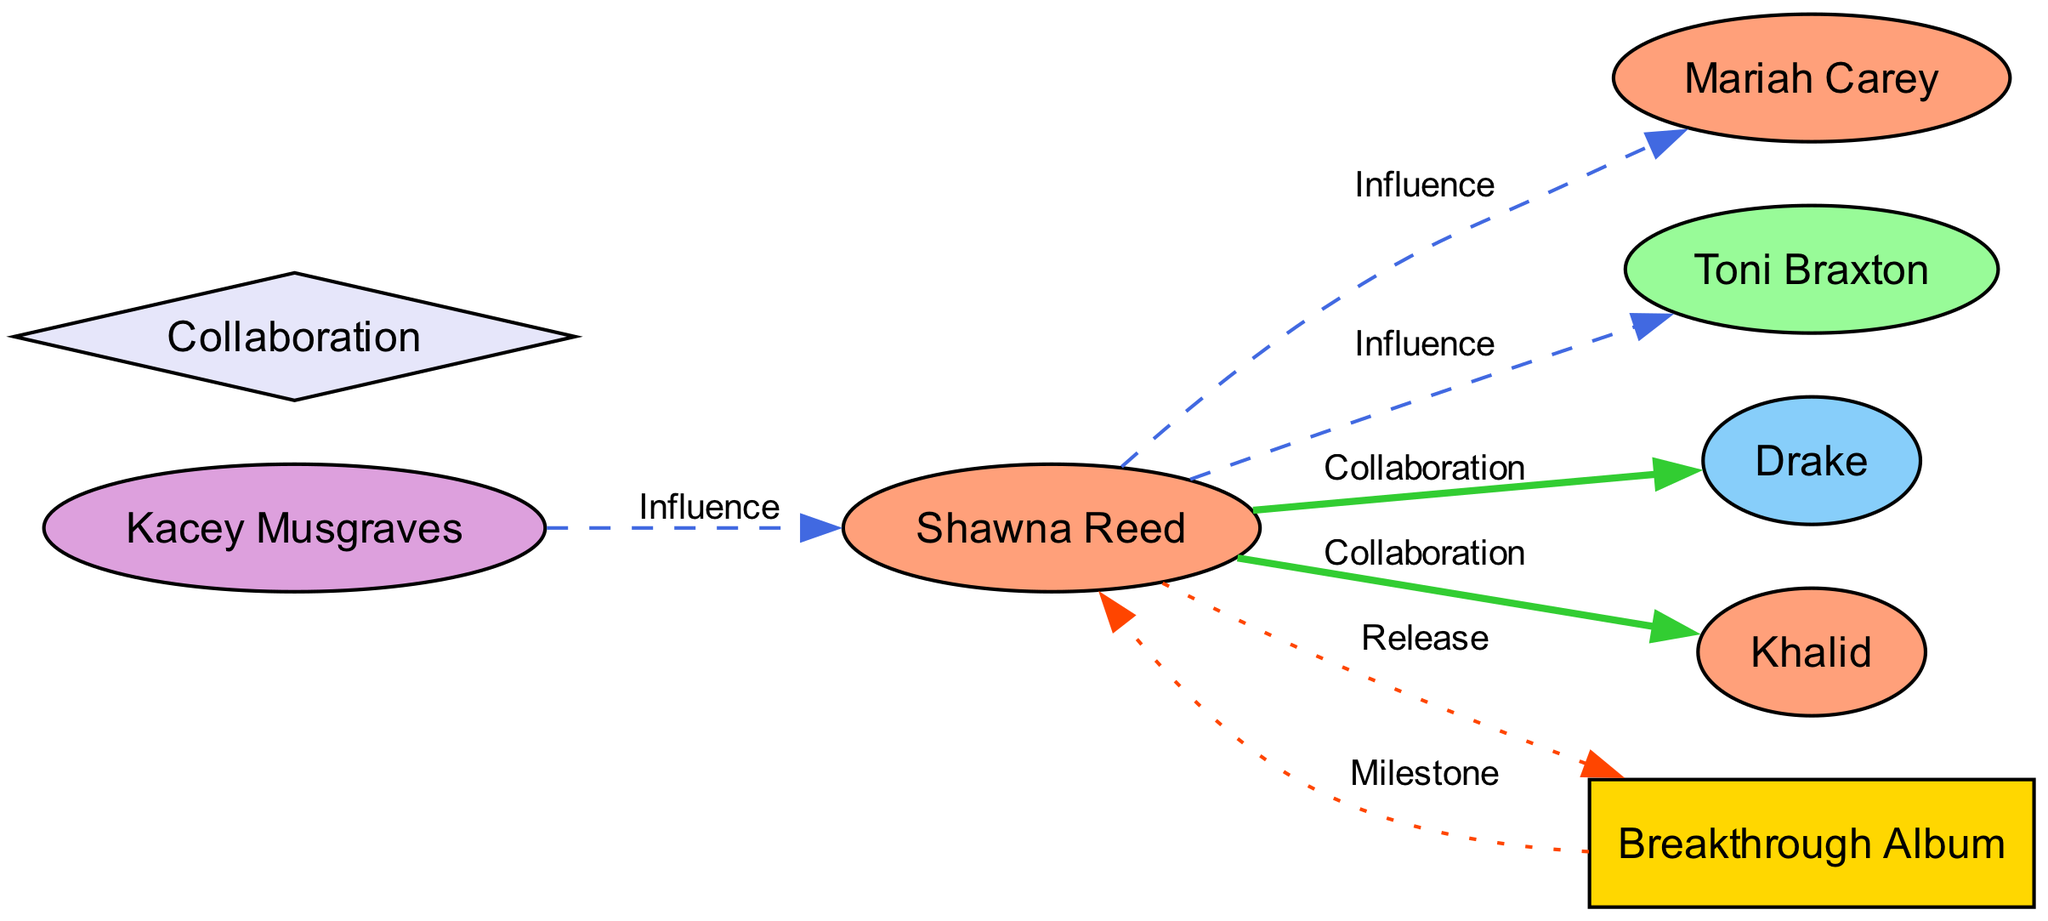What is Shawna Reed's primary genre? The label associated with Shawna Reed in the diagram is "Pop/R&B," which indicates that her primary genre is Pop/R&B.
Answer: Pop/R&B Who did Shawna Reed collaborate with? The diagram shows two directed edges stemming from Shawna Reed labeled "Collaboration" towards Drake and Khalid, indicating that these are the artists with whom she collaborated.
Answer: Drake, Khalid How many influences does Shawna Reed have? By counting the edges directed toward Shawna Reed labeled "Influence" from Mariah Carey, Toni Braxton, and Kacey Musgraves, it is clear that she has three influences.
Answer: 3 What event is marked as a milestone for Shawna Reed? The diagram indicates a directed edge labeled "Milestone" from "Breakthrough Album" to Shawna Reed, suggesting "Breakthrough Album" is the event marking a significant milestone in her career.
Answer: Breakthrough Album Which artist influenced Kacey Musgraves? The arrow pointing from Kacey Musgraves to Shawna Reed labeled "Influence" indicates that Shawna Reed is the artist who influenced Kacey Musgraves.
Answer: Shawna Reed What type of event is "Collaboration"? In the diagram, "Collaboration" is categorized under the type "Event," as shown by its definition in the node attributes.
Answer: Event How many total nodes are there in the diagram? Summing all the nodes listed, there are a total of seven nodes: Shawna Reed, Mariah Carey, Toni Braxton, Drake, Khalid, Kacey Musgraves, and Breakthrough Album.
Answer: 7 Which genre is Kacey Musgraves associated with? Kacey Musgraves is labeled in the diagram with the genre "Country," which defines her association.
Answer: Country Which edge represents an influence from Shawna Reed? The edges labeled "Influence" from Shawna Reed to Mariah Carey and Toni Braxton both represent influences that Shawna Reed has on these artists.
Answer: Mariah Carey, Toni Braxton 